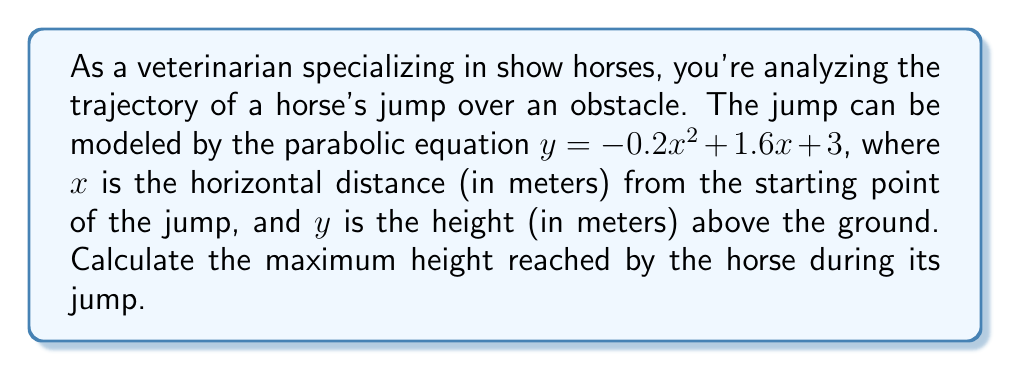Give your solution to this math problem. To find the maximum height of the horse's jump, we need to determine the vertex of the parabola. The general form of a quadratic equation is $y = ax^2 + bx + c$, where $(h, k)$ is the vertex of the parabola.

Given equation: $y = -0.2x^2 + 1.6x + 3$

1) For a parabola $y = ax^2 + bx + c$, the x-coordinate of the vertex is given by $x = -\frac{b}{2a}$

2) In this case, $a = -0.2$ and $b = 1.6$

3) $x = -\frac{1.6}{2(-0.2)} = -\frac{1.6}{-0.4} = 4$

4) To find the y-coordinate (maximum height), substitute $x = 4$ into the original equation:

   $y = -0.2(4)^2 + 1.6(4) + 3$
   $y = -0.2(16) + 6.4 + 3$
   $y = -3.2 + 6.4 + 3$
   $y = 6.2$

5) Therefore, the vertex of the parabola is (4, 6.2)

The y-coordinate of the vertex represents the maximum height reached by the horse during its jump.
Answer: The maximum height reached by the horse during its jump is 6.2 meters. 